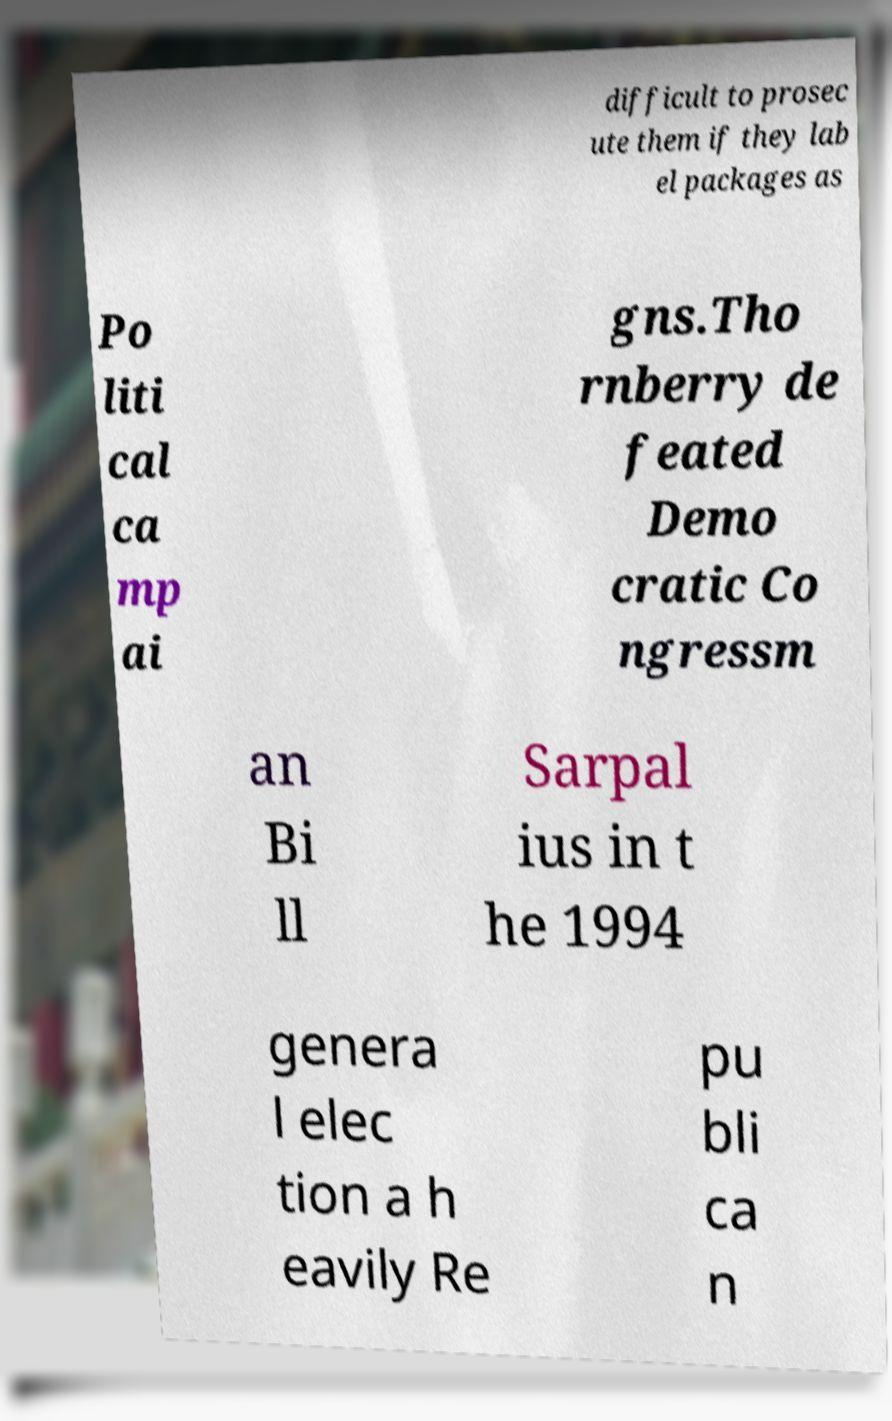Can you read and provide the text displayed in the image?This photo seems to have some interesting text. Can you extract and type it out for me? difficult to prosec ute them if they lab el packages as Po liti cal ca mp ai gns.Tho rnberry de feated Demo cratic Co ngressm an Bi ll Sarpal ius in t he 1994 genera l elec tion a h eavily Re pu bli ca n 